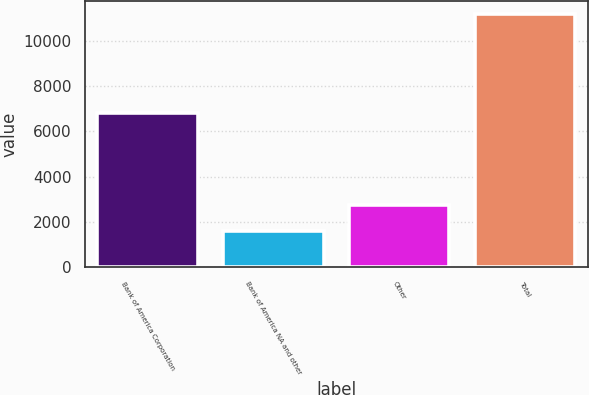Convert chart to OTSL. <chart><loc_0><loc_0><loc_500><loc_500><bar_chart><fcel>Bank of America Corporation<fcel>Bank of America NA and other<fcel>Other<fcel>Total<nl><fcel>6834<fcel>1615<fcel>2739<fcel>11188<nl></chart> 